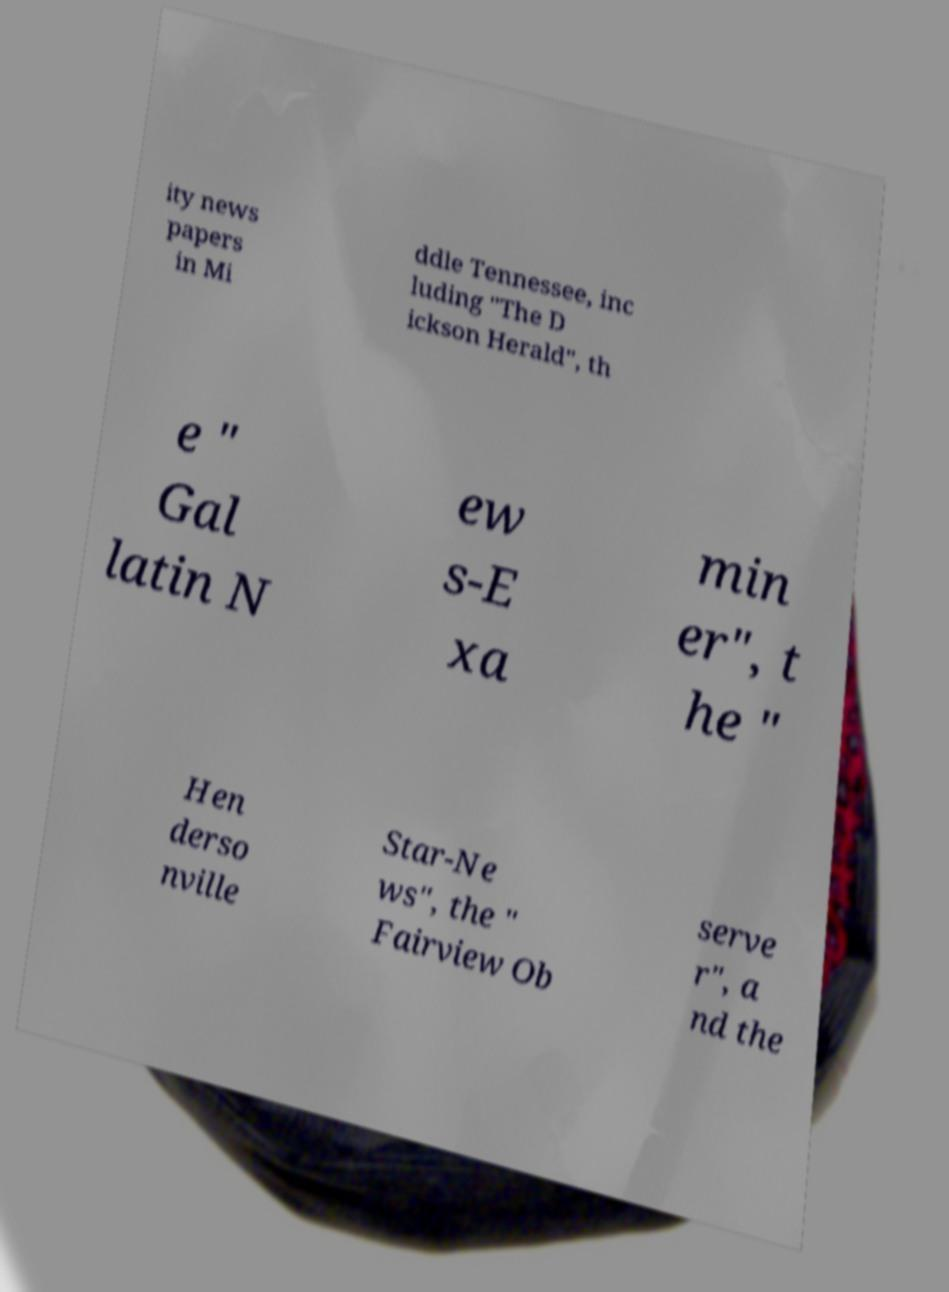I need the written content from this picture converted into text. Can you do that? ity news papers in Mi ddle Tennessee, inc luding "The D ickson Herald", th e " Gal latin N ew s-E xa min er", t he " Hen derso nville Star-Ne ws", the " Fairview Ob serve r", a nd the 